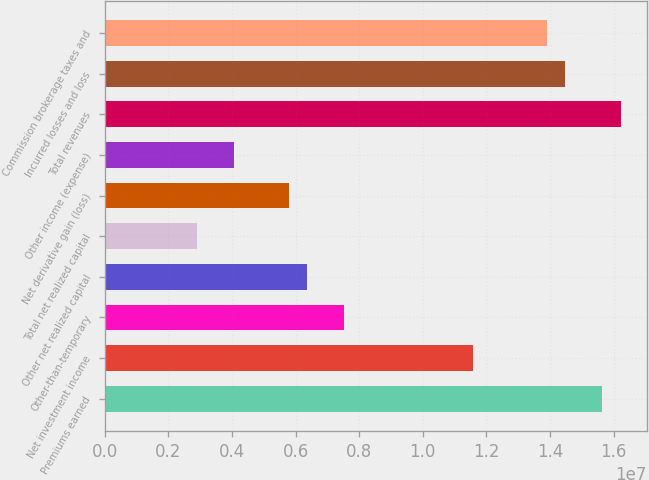<chart> <loc_0><loc_0><loc_500><loc_500><bar_chart><fcel>Premiums earned<fcel>Net investment income<fcel>Other-than-temporary<fcel>Other net realized capital<fcel>Total net realized capital<fcel>Net derivative gain (loss)<fcel>Other income (expense)<fcel>Total revenues<fcel>Incurred losses and loss<fcel>Commission brokerage taxes and<nl><fcel>1.56447e+07<fcel>1.15887e+07<fcel>7.53265e+06<fcel>6.37378e+06<fcel>2.89718e+06<fcel>5.79435e+06<fcel>4.05604e+06<fcel>1.62242e+07<fcel>1.44859e+07<fcel>1.39064e+07<nl></chart> 